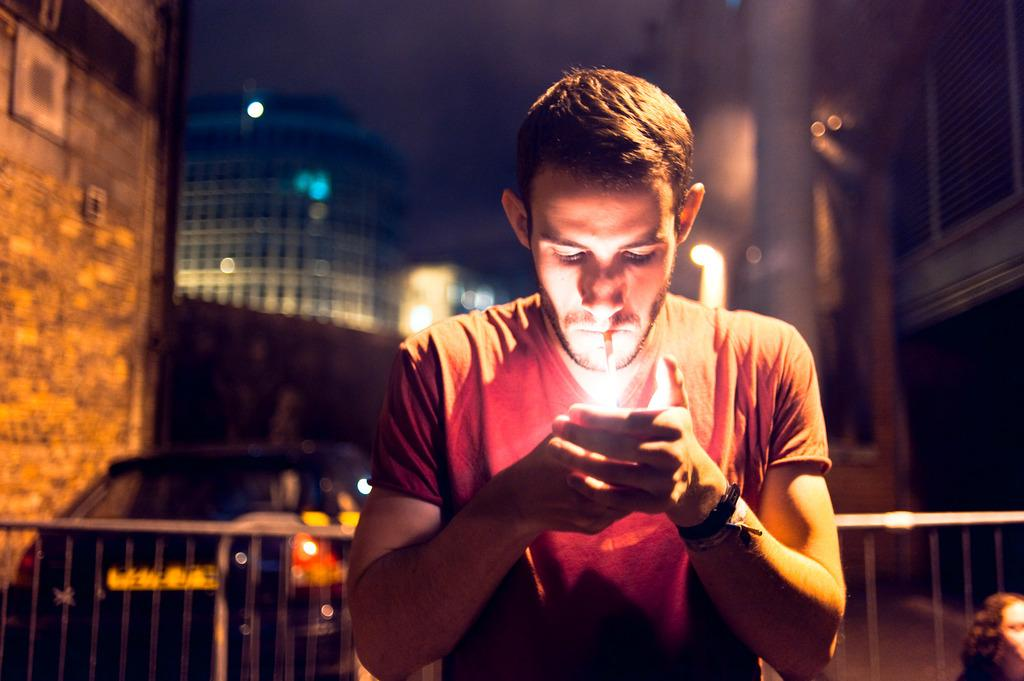What is the person in the image wearing? The person is wearing a red T-shirt. What is the person doing in the image? The person is lighting a cigarette. What can be seen in the background of the image? There is a fencing, a car, and buildings on either side of the person. What type of drug is the person taking in the image? There is no drug present in the image; the person is lighting a cigarette. What is the person laughing at in the image? There is no indication of the person laughing in the image. 